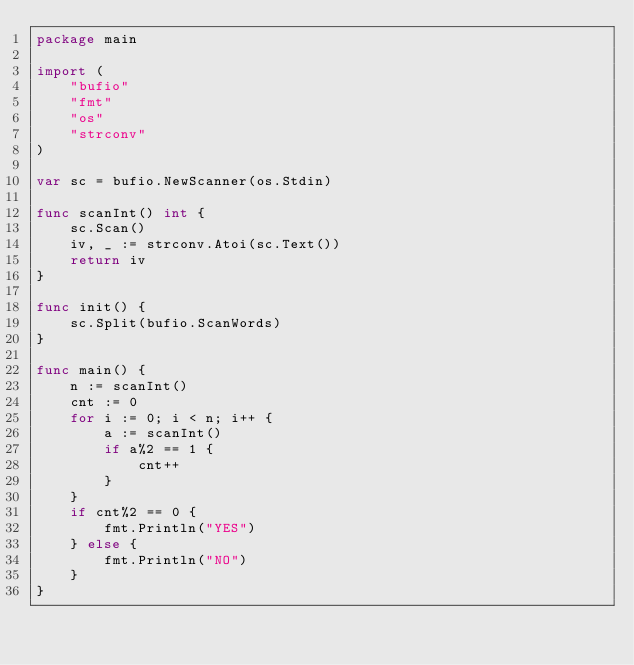Convert code to text. <code><loc_0><loc_0><loc_500><loc_500><_Go_>package main

import (
	"bufio"
	"fmt"
	"os"
	"strconv"
)

var sc = bufio.NewScanner(os.Stdin)

func scanInt() int {
	sc.Scan()
	iv, _ := strconv.Atoi(sc.Text())
	return iv
}

func init() {
	sc.Split(bufio.ScanWords)
}

func main() {
	n := scanInt()
	cnt := 0
	for i := 0; i < n; i++ {
		a := scanInt()
		if a%2 == 1 {
			cnt++
		}
	}
	if cnt%2 == 0 {
		fmt.Println("YES")
	} else {
		fmt.Println("NO")
	}
}
</code> 